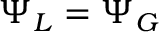Convert formula to latex. <formula><loc_0><loc_0><loc_500><loc_500>\Psi _ { L } = \Psi _ { G }</formula> 